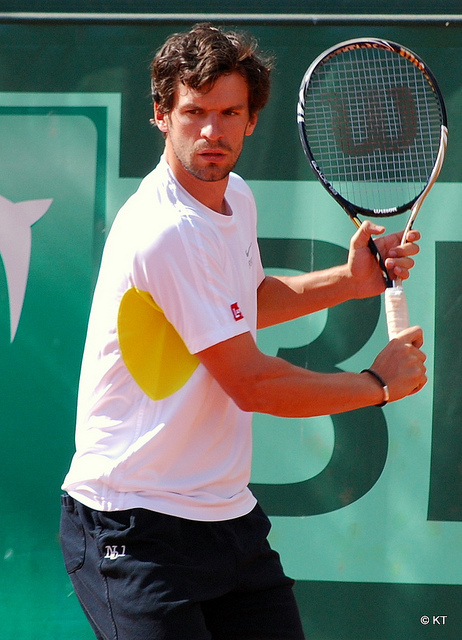<image>What athlete is this? I don't know who the athlete is. It could be a tennis player or specifically Pete Sampras. Who is the sponsor of the US OPEN SERIES? It is unclear who the sponsor of the US OPEN SERIES is. It could be Wilson, 3M, Nike, or Birch series. What athlete is this? I am not aware of what athlete is in the image. It can be a tennis player, specifically Pete Sampras. Who is the sponsor of the US OPEN SERIES? I don't know who is the sponsor of the US OPEN SERIES. It can be Wilson, 3M, Nike, or Birch series. 